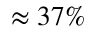Convert formula to latex. <formula><loc_0><loc_0><loc_500><loc_500>\approx 3 7 \%</formula> 